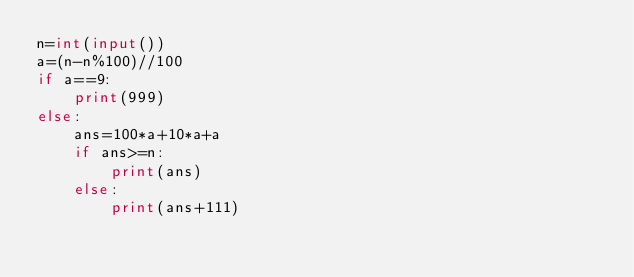Convert code to text. <code><loc_0><loc_0><loc_500><loc_500><_Python_>n=int(input())
a=(n-n%100)//100
if a==9:
    print(999)
else:
    ans=100*a+10*a+a
    if ans>=n:
        print(ans)
    else:
        print(ans+111)
</code> 